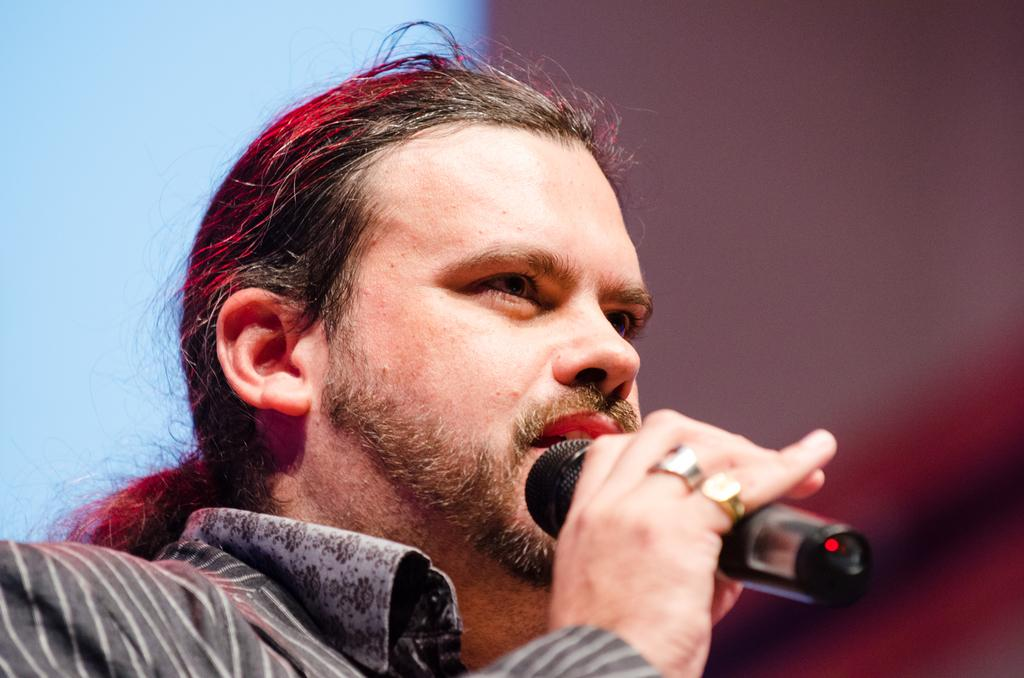What is the main subject of the image? There is a person in the image. What is the person holding in the image? The person is holding a mic. Can you describe the person's attire in the image? The person is wearing a black and grey color dress. How would you describe the background of the image? The background of the image is blurred. What type of offer is the person making in the image? There is no indication in the image that the person is making any offer. What rhythm is the person following while holding the mic? There is no indication of rhythm or any musical activity in the image. 